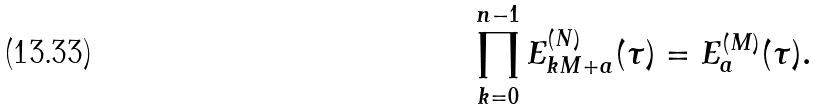<formula> <loc_0><loc_0><loc_500><loc_500>\prod _ { k = 0 } ^ { n - 1 } E _ { k M + a } ^ { ( N ) } ( \tau ) = E _ { a } ^ { ( M ) } ( \tau ) .</formula> 